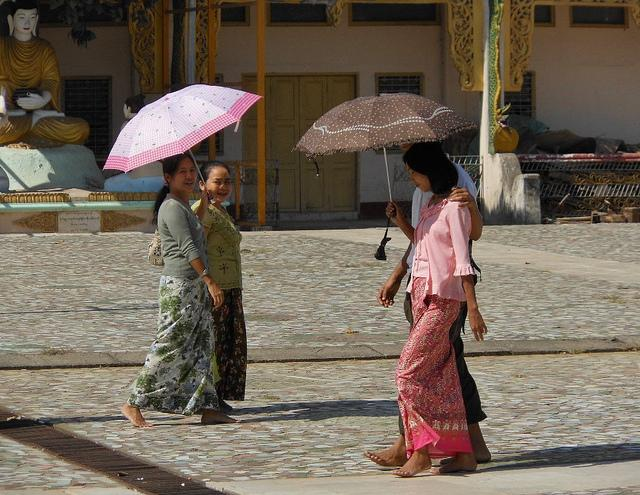Why are umbrellas being used today? sun 